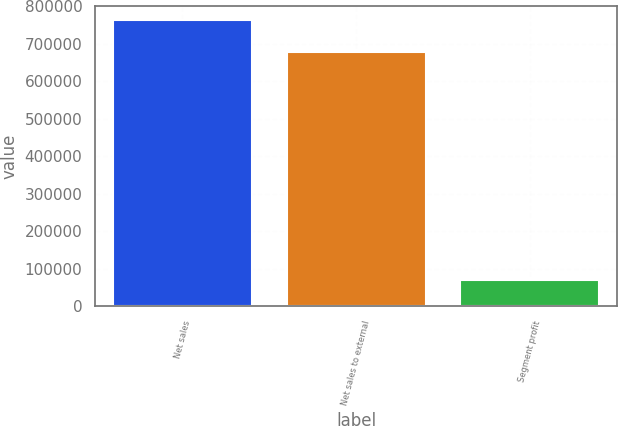Convert chart to OTSL. <chart><loc_0><loc_0><loc_500><loc_500><bar_chart><fcel>Net sales<fcel>Net sales to external<fcel>Segment profit<nl><fcel>762717<fcel>679083<fcel>71124<nl></chart> 